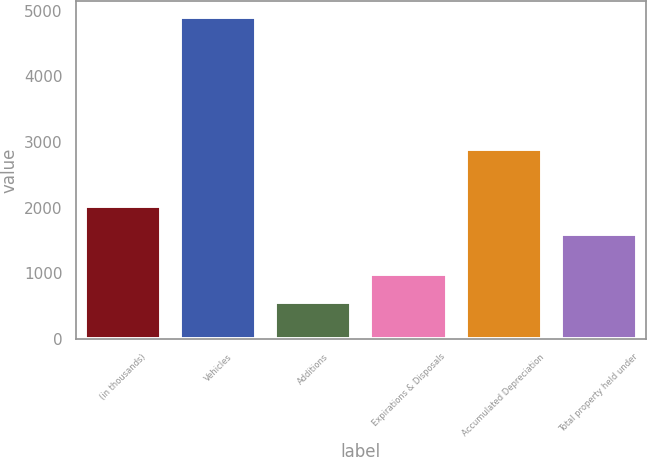Convert chart. <chart><loc_0><loc_0><loc_500><loc_500><bar_chart><fcel>(in thousands)<fcel>Vehicles<fcel>Additions<fcel>Expirations & Disposals<fcel>Accumulated Depreciation<fcel>Total property held under<nl><fcel>2030.5<fcel>4904<fcel>559<fcel>993.5<fcel>2888<fcel>1596<nl></chart> 